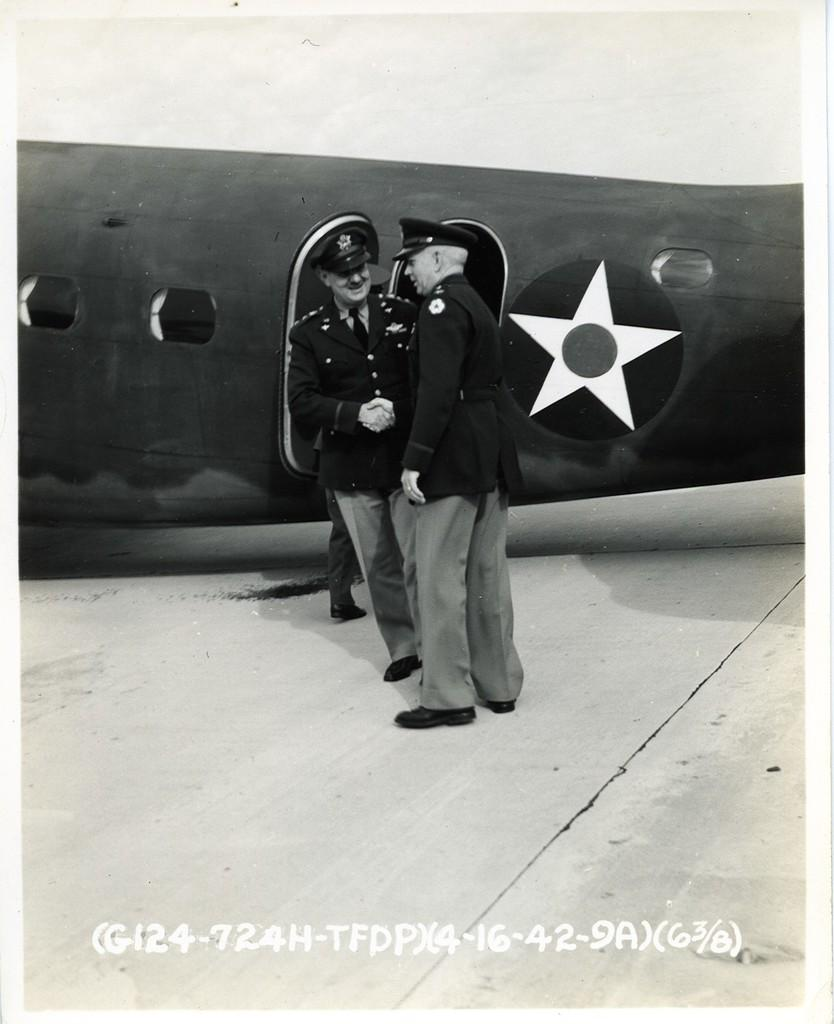What is the main subject of the image? The main subject of the image is an aircraft. Can you describe the people in the image? There are two men standing in the image. Is there any text present in the image? Yes, there is some text visible at the bottom of the image. What type of notebook is the man holding in the image? There is no man holding a notebook in the image. Is there any mention of a birthday celebration in the image? There is no reference to a birthday celebration in the image. 